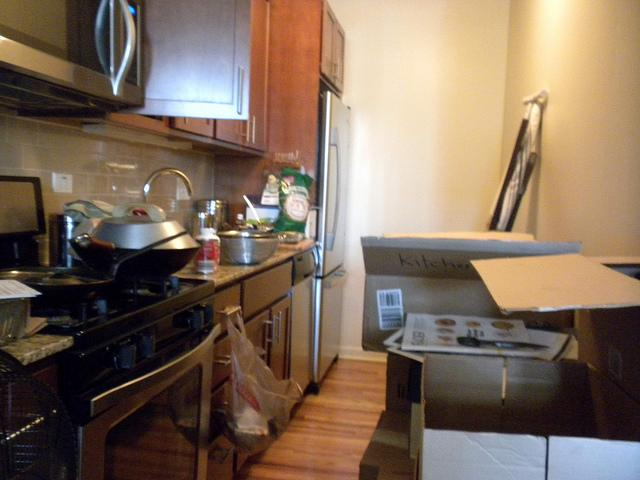What does the cardboard box tell us about this situation? Please explain your reasoning. moving in. The box says "kitchen" on it and that's what people do when they move to another place. 